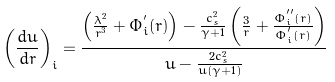<formula> <loc_0><loc_0><loc_500><loc_500>\left ( \frac { d u } { d r } \right ) _ { i } = \frac { \left ( \frac { \lambda ^ { 2 } } { r ^ { 3 } } + \Phi ^ { ^ { \prime } } _ { i } ( r ) \right ) - \frac { c _ { s } ^ { 2 } } { \gamma + 1 } \left ( \frac { 3 } { r } + \frac { \Phi ^ { ^ { \prime \prime } } _ { i } ( r ) } { \Phi ^ { ^ { \prime } } _ { i } ( r ) } \right ) } { u - \frac { 2 c _ { s } ^ { 2 } } { u \left ( \gamma + 1 \right ) } }</formula> 